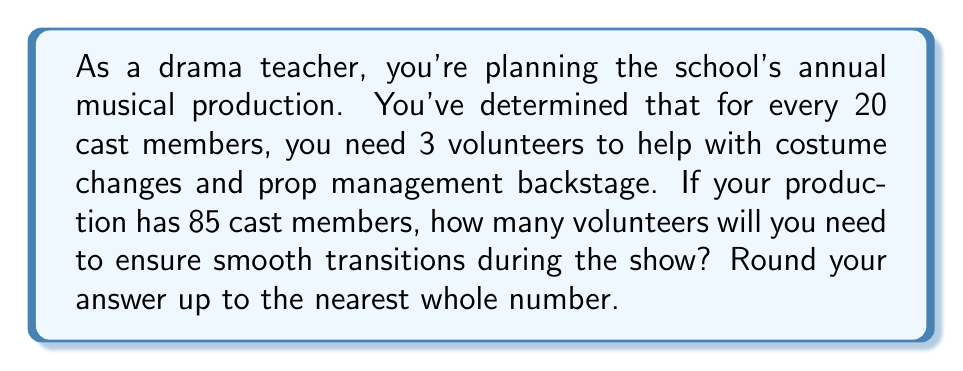Solve this math problem. Let's approach this step-by-step:

1) First, we need to set up a proportion to represent the relationship between cast members and volunteers:
   
   $$\frac{20 \text{ cast members}}{3 \text{ volunteers}} = \frac{85 \text{ cast members}}{x \text{ volunteers}}$$

2) Now, we can cross-multiply to solve for x:
   
   $$20x = 3 \cdot 85$$

3) Simplify the right side:
   
   $$20x = 255$$

4) Divide both sides by 20:
   
   $$x = \frac{255}{20} = 12.75$$

5) Since we can't have a fractional number of volunteers, and the question asks to round up to the nearest whole number, we need to ceil this value.

6) Therefore, the final answer is 13 volunteers.

This calculation ensures that you'll have slightly more help than the strict ratio requires, which is beneficial for a smooth-running production.
Answer: 13 volunteers 